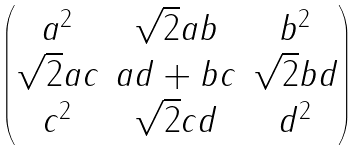<formula> <loc_0><loc_0><loc_500><loc_500>\begin{pmatrix} a ^ { 2 } & \sqrt { 2 } a b & b ^ { 2 } \\ \sqrt { 2 } a c & a d + b c & \sqrt { 2 } b d \\ c ^ { 2 } & \sqrt { 2 } c d & d ^ { 2 } \end{pmatrix}</formula> 